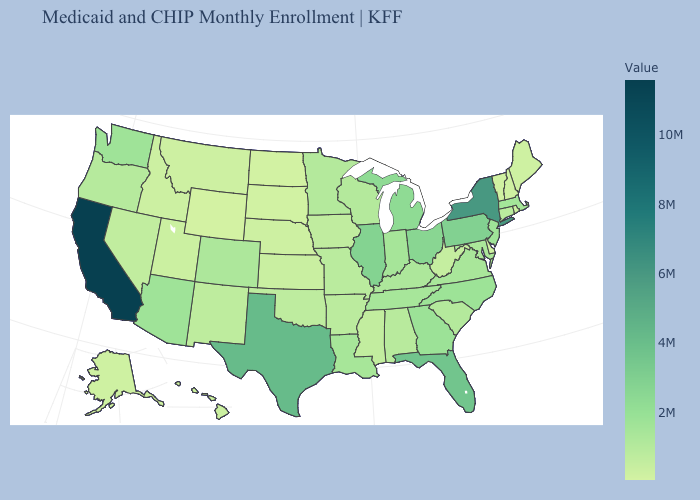Does California have the highest value in the West?
Write a very short answer. Yes. Among the states that border Georgia , does North Carolina have the highest value?
Answer briefly. No. Which states hav the highest value in the West?
Keep it brief. California. Does New Hampshire have the highest value in the Northeast?
Short answer required. No. Which states have the lowest value in the USA?
Keep it brief. Wyoming. Which states have the lowest value in the USA?
Be succinct. Wyoming. Among the states that border Montana , does South Dakota have the lowest value?
Answer briefly. No. Among the states that border Texas , does Oklahoma have the highest value?
Answer briefly. No. 